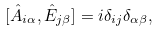<formula> <loc_0><loc_0><loc_500><loc_500>[ \hat { A } _ { i \alpha } , \hat { E } _ { j \beta } ] = i \delta _ { i j } \delta _ { \alpha \beta } ,</formula> 